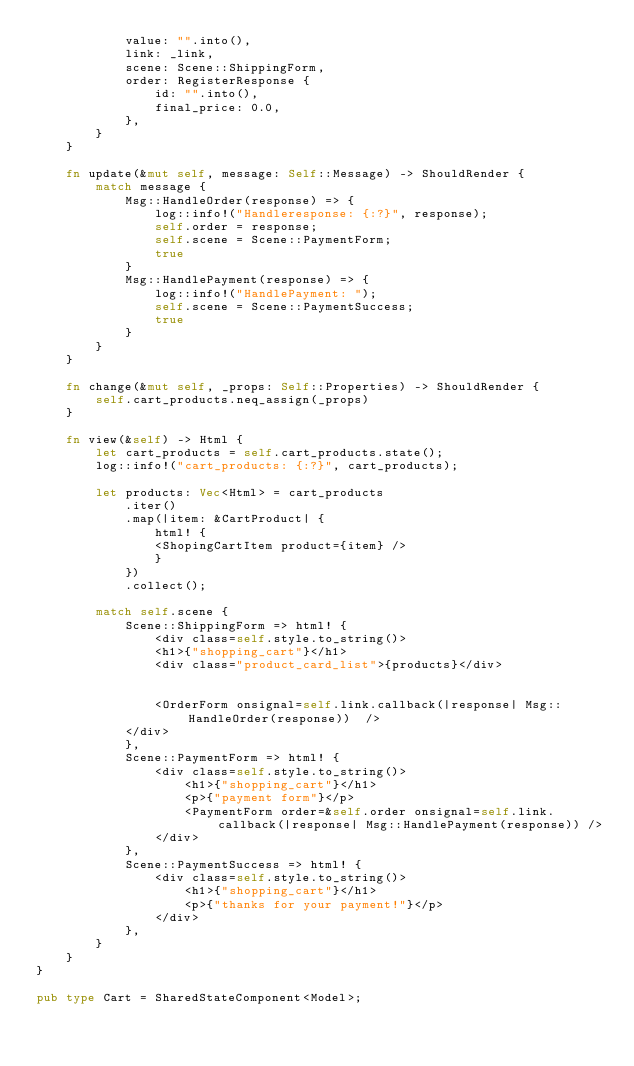Convert code to text. <code><loc_0><loc_0><loc_500><loc_500><_Rust_>            value: "".into(),
            link: _link,
            scene: Scene::ShippingForm,
            order: RegisterResponse {
                id: "".into(),
                final_price: 0.0,
            },
        }
    }

    fn update(&mut self, message: Self::Message) -> ShouldRender {
        match message {
            Msg::HandleOrder(response) => {
                log::info!("Handleresponse: {:?}", response);
                self.order = response;
                self.scene = Scene::PaymentForm;
                true
            }
            Msg::HandlePayment(response) => {
                log::info!("HandlePayment: ");
                self.scene = Scene::PaymentSuccess;
                true
            }
        }
    }

    fn change(&mut self, _props: Self::Properties) -> ShouldRender {
        self.cart_products.neq_assign(_props)
    }

    fn view(&self) -> Html {
        let cart_products = self.cart_products.state();
        log::info!("cart_products: {:?}", cart_products);

        let products: Vec<Html> = cart_products
            .iter()
            .map(|item: &CartProduct| {
                html! {
                <ShopingCartItem product={item} />
                }
            })
            .collect();

        match self.scene {
            Scene::ShippingForm => html! {
                <div class=self.style.to_string()>
                <h1>{"shopping_cart"}</h1>
                <div class="product_card_list">{products}</div>


                <OrderForm onsignal=self.link.callback(|response| Msg::HandleOrder(response))  />
            </div>
            },
            Scene::PaymentForm => html! {
                <div class=self.style.to_string()>
                    <h1>{"shopping_cart"}</h1>
                    <p>{"payment form"}</p>
                    <PaymentForm order=&self.order onsignal=self.link.callback(|response| Msg::HandlePayment(response)) />
                </div>
            },
            Scene::PaymentSuccess => html! {
                <div class=self.style.to_string()>
                    <h1>{"shopping_cart"}</h1>
                    <p>{"thanks for your payment!"}</p>
                </div>
            },
        }
    }
}

pub type Cart = SharedStateComponent<Model>;
</code> 